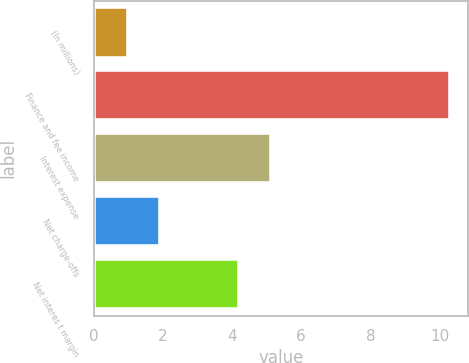<chart> <loc_0><loc_0><loc_500><loc_500><bar_chart><fcel>(In millions)<fcel>Finance and fee income<fcel>Interest expense<fcel>Net charge-offs<fcel>Net interes t margin<nl><fcel>1<fcel>10.3<fcel>5.13<fcel>1.93<fcel>4.2<nl></chart> 